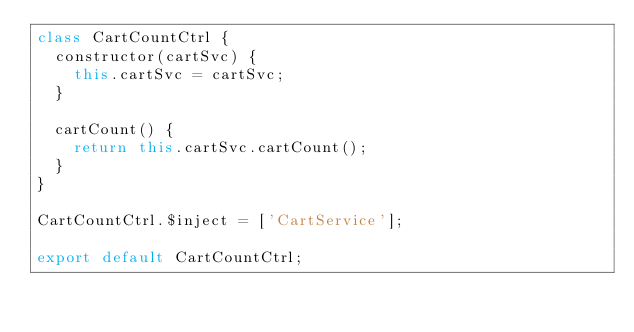Convert code to text. <code><loc_0><loc_0><loc_500><loc_500><_JavaScript_>class CartCountCtrl {
  constructor(cartSvc) {
    this.cartSvc = cartSvc;
  }

  cartCount() {
    return this.cartSvc.cartCount();
  }
}

CartCountCtrl.$inject = ['CartService'];

export default CartCountCtrl;
</code> 